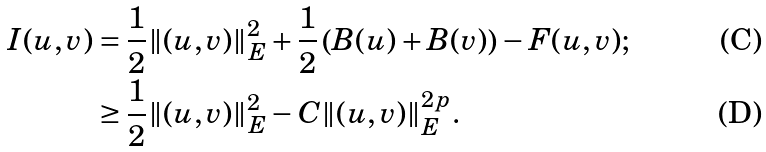Convert formula to latex. <formula><loc_0><loc_0><loc_500><loc_500>I ( u , v ) & = \frac { 1 } { 2 } \| ( u , v ) \| _ { E } ^ { 2 } + \frac { 1 } { 2 } \left ( B ( u ) + B ( v ) \right ) - F ( u , v ) ; \\ & \geq \frac { 1 } { 2 } \| ( u , v ) \| _ { E } ^ { 2 } - C \| ( u , v ) \| _ { E } ^ { 2 p } .</formula> 